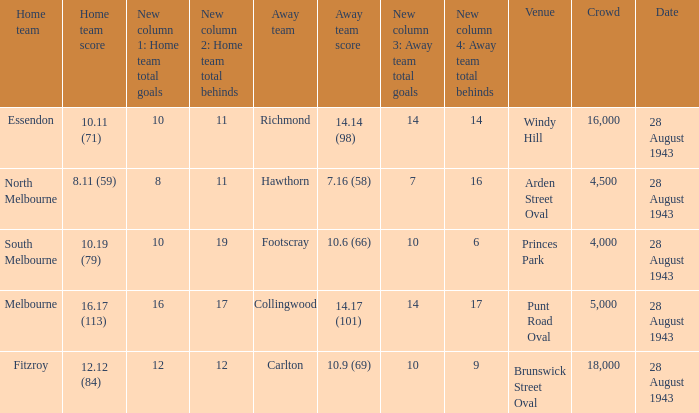What game showed a home team score of 8.11 (59)? 28 August 1943. 